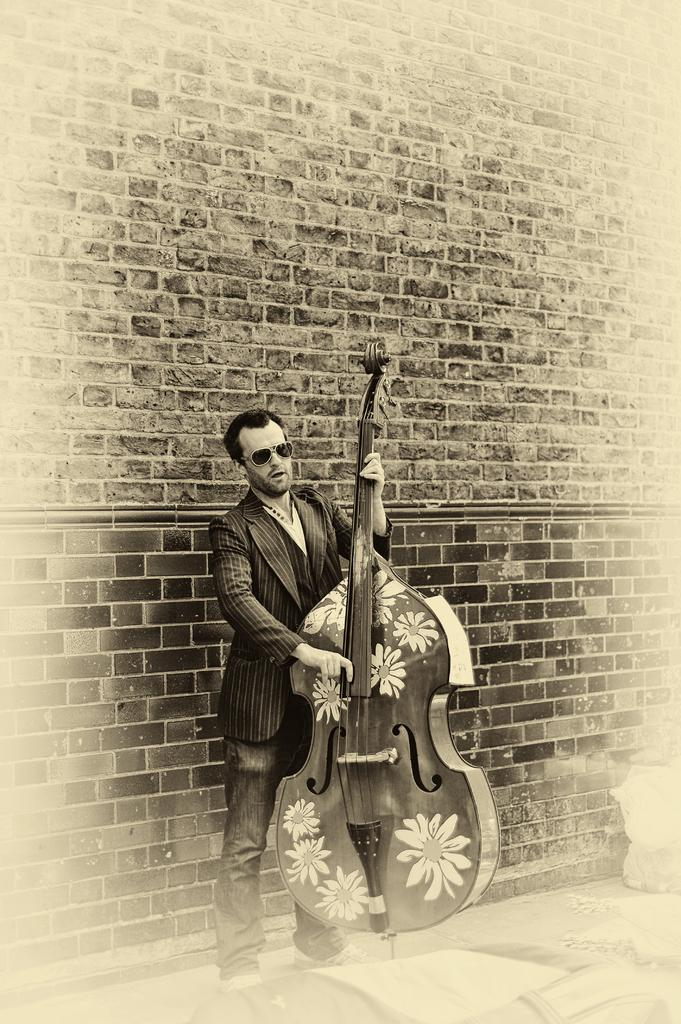What is the main subject in the foreground of the image? There is a man in the foreground of the image. What is the man holding in the image? The man is holding a violin. Can you describe the object at the bottom of the image? Unfortunately, the facts provided do not give any information about the object at the bottom of the image. What can be seen in the background of the image? There is a brick wall in the background of the image. What type of beef is being served on the tray in the image? There is no tray or beef present in the image. What language is the man speaking in the image? The facts provided do not give any information about the language being spoken in the image. 